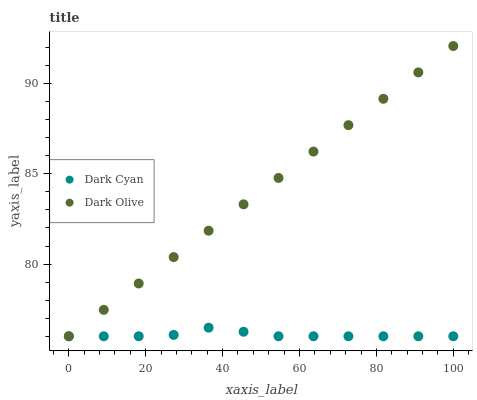Does Dark Cyan have the minimum area under the curve?
Answer yes or no. Yes. Does Dark Olive have the maximum area under the curve?
Answer yes or no. Yes. Does Dark Olive have the minimum area under the curve?
Answer yes or no. No. Is Dark Olive the smoothest?
Answer yes or no. Yes. Is Dark Cyan the roughest?
Answer yes or no. Yes. Is Dark Olive the roughest?
Answer yes or no. No. Does Dark Cyan have the lowest value?
Answer yes or no. Yes. Does Dark Olive have the highest value?
Answer yes or no. Yes. Does Dark Cyan intersect Dark Olive?
Answer yes or no. Yes. Is Dark Cyan less than Dark Olive?
Answer yes or no. No. Is Dark Cyan greater than Dark Olive?
Answer yes or no. No. 